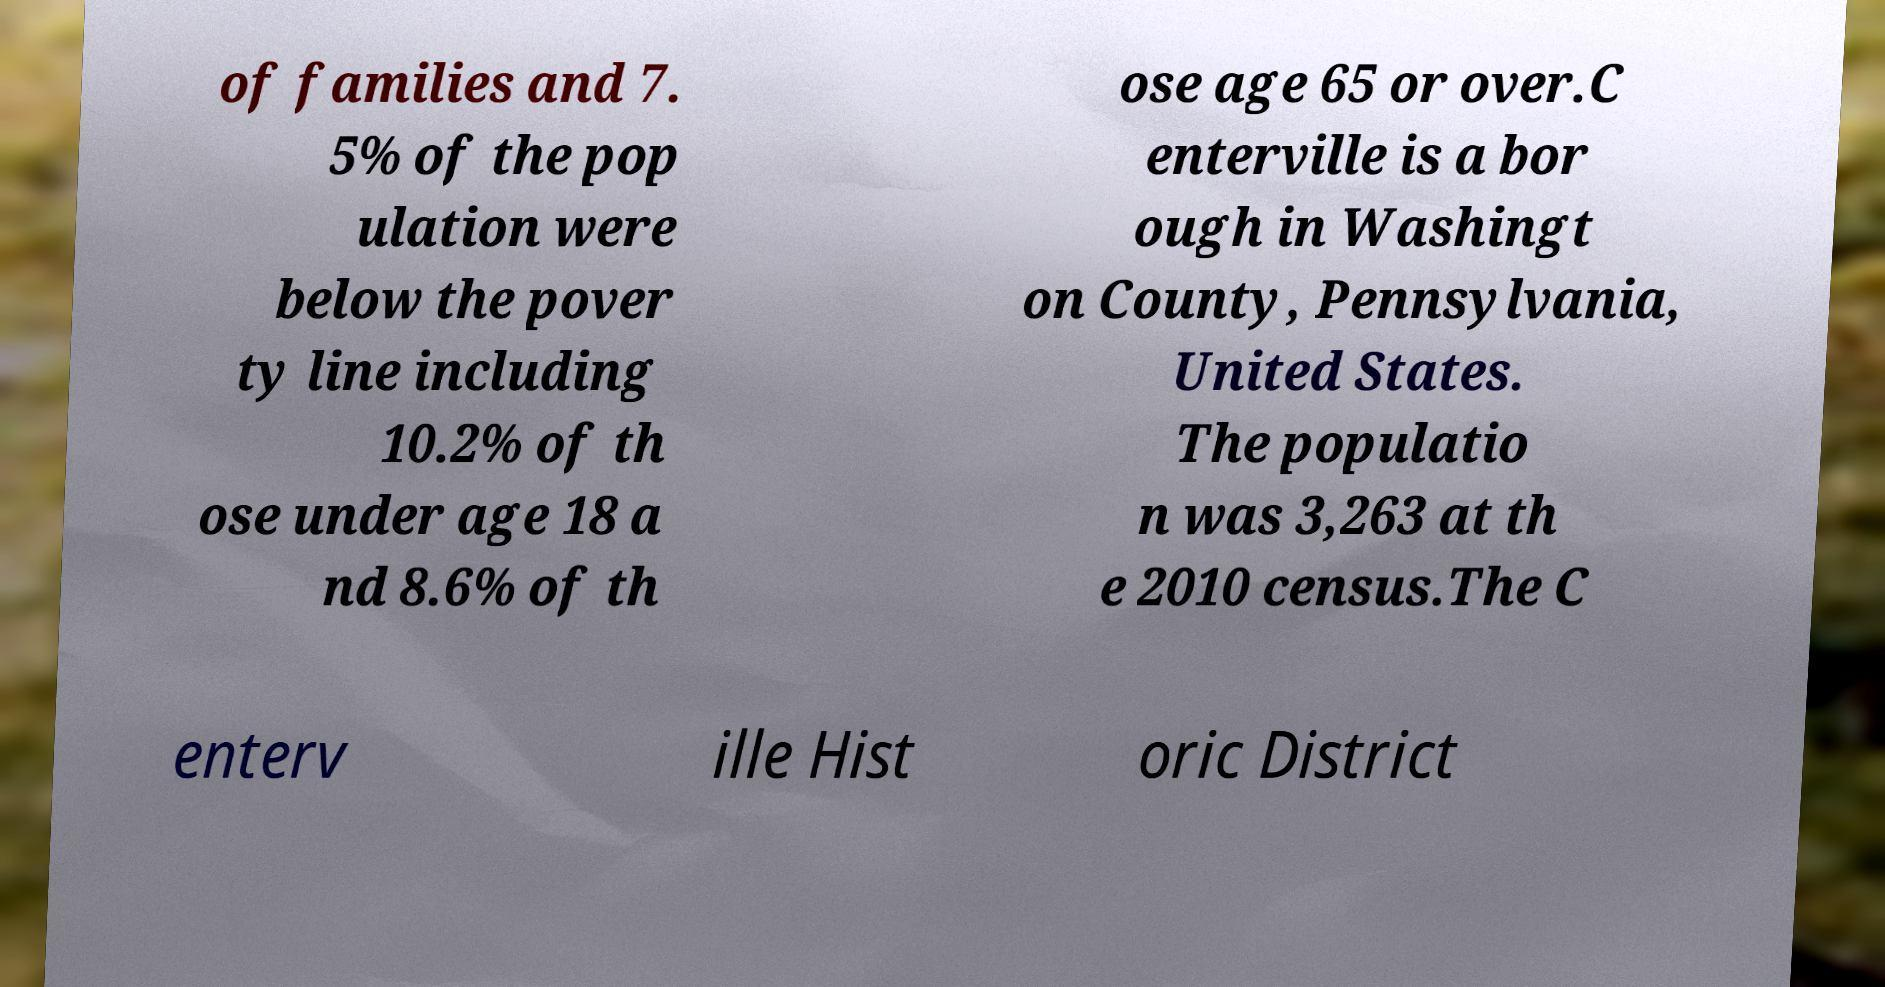I need the written content from this picture converted into text. Can you do that? of families and 7. 5% of the pop ulation were below the pover ty line including 10.2% of th ose under age 18 a nd 8.6% of th ose age 65 or over.C enterville is a bor ough in Washingt on County, Pennsylvania, United States. The populatio n was 3,263 at th e 2010 census.The C enterv ille Hist oric District 